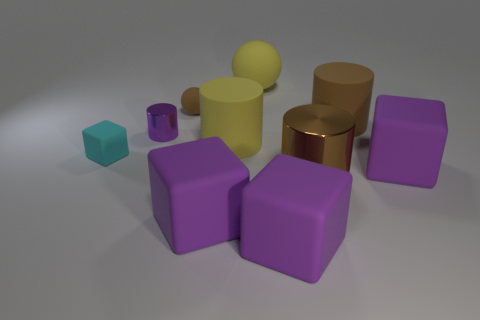How many objects are there, and can you describe their shapes? In the image, there are a total of nine objects. Starting from the left, there's a small cyan cube, moving right there are three purple cubes, behind those a large and a small yellow sphere, continuing right two brown cylinders, and lastly on the far right, a purple cylinder. 